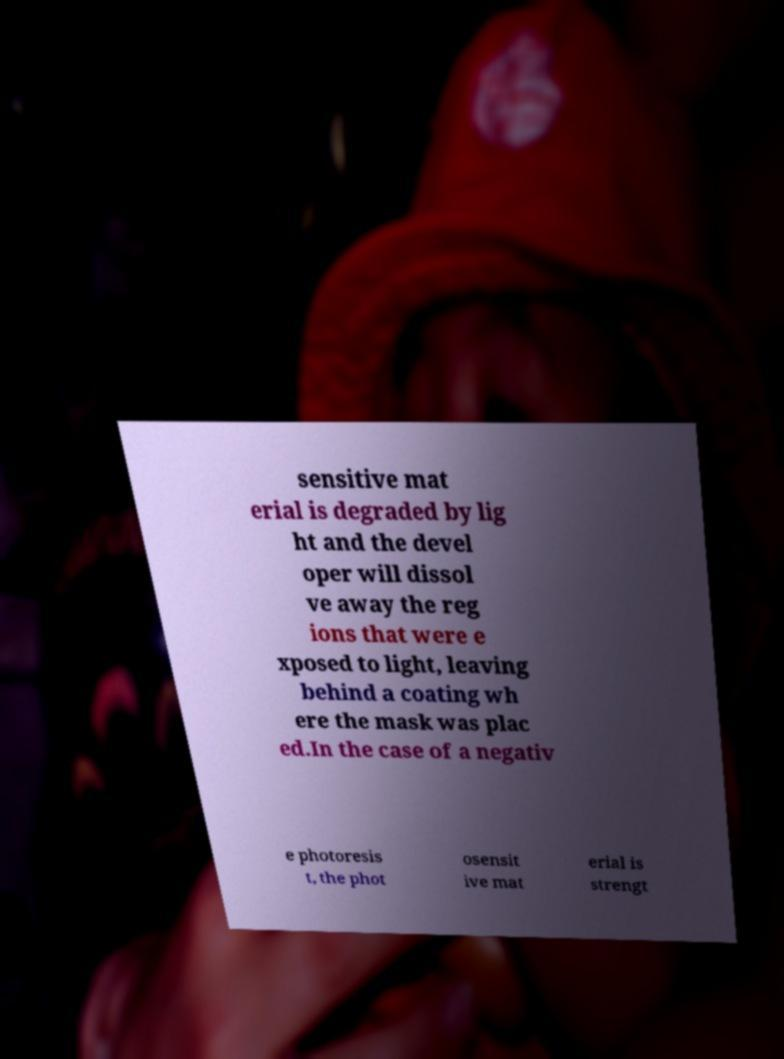What messages or text are displayed in this image? I need them in a readable, typed format. sensitive mat erial is degraded by lig ht and the devel oper will dissol ve away the reg ions that were e xposed to light, leaving behind a coating wh ere the mask was plac ed.In the case of a negativ e photoresis t, the phot osensit ive mat erial is strengt 